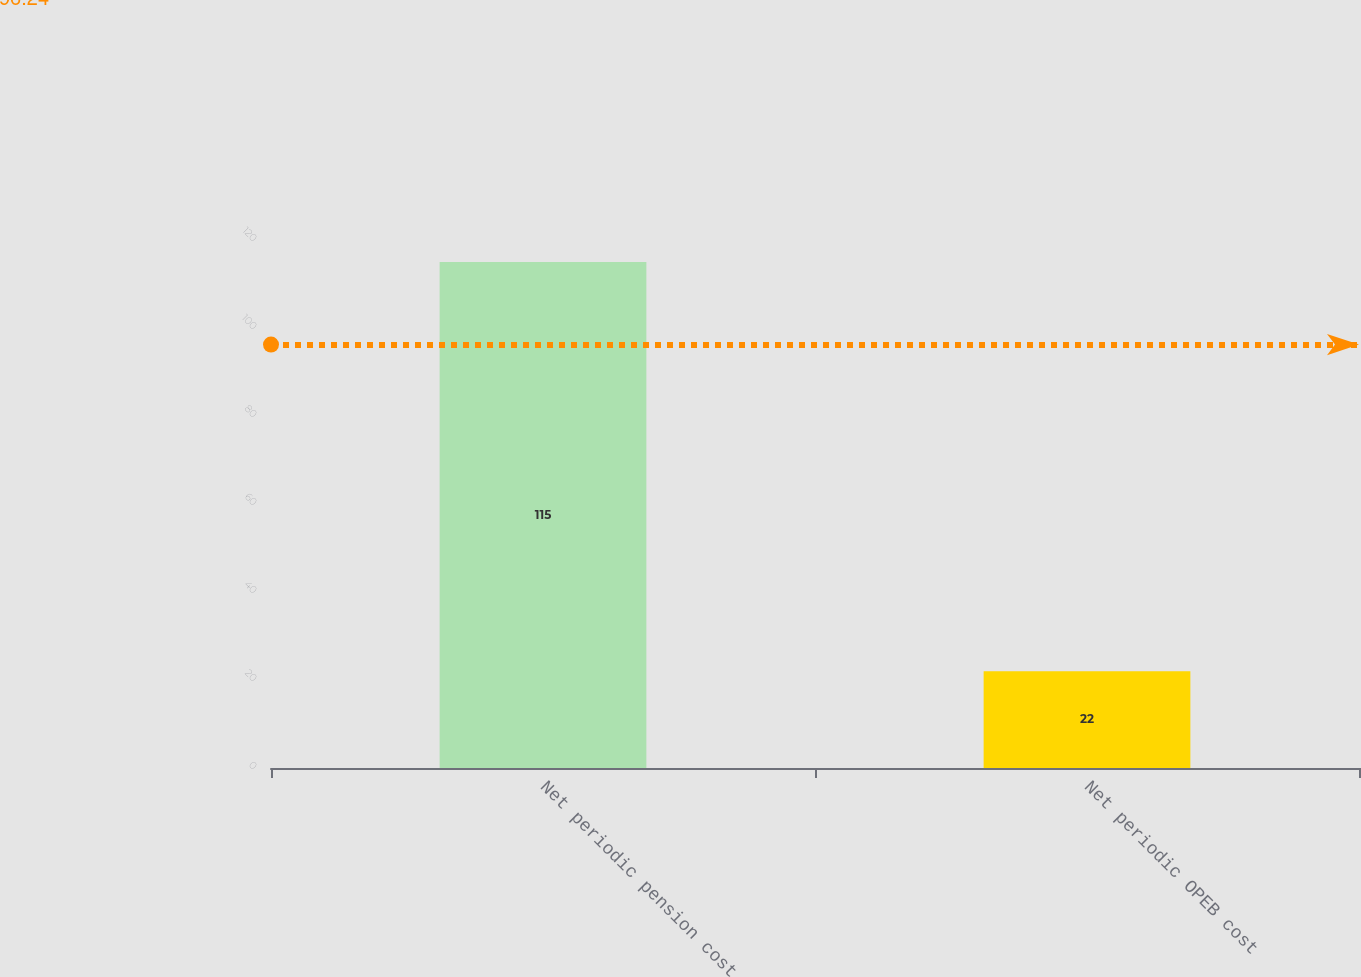Convert chart to OTSL. <chart><loc_0><loc_0><loc_500><loc_500><bar_chart><fcel>Net periodic pension cost<fcel>Net periodic OPEB cost<nl><fcel>115<fcel>22<nl></chart> 